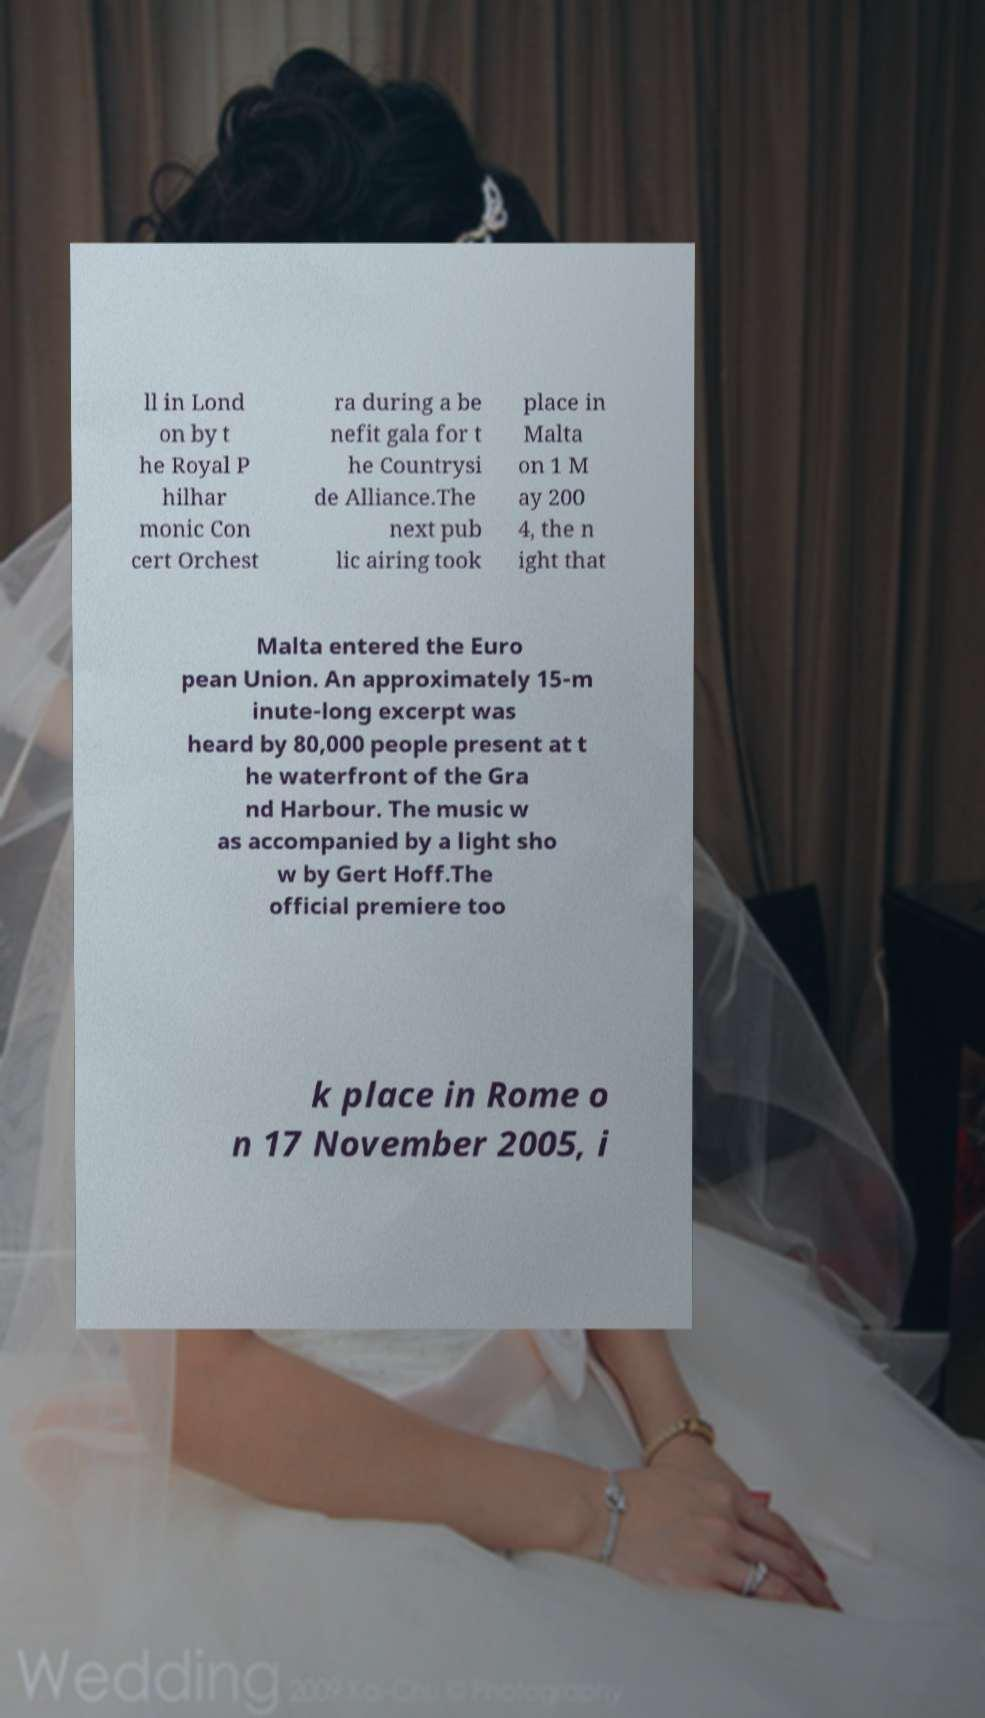For documentation purposes, I need the text within this image transcribed. Could you provide that? ll in Lond on by t he Royal P hilhar monic Con cert Orchest ra during a be nefit gala for t he Countrysi de Alliance.The next pub lic airing took place in Malta on 1 M ay 200 4, the n ight that Malta entered the Euro pean Union. An approximately 15-m inute-long excerpt was heard by 80,000 people present at t he waterfront of the Gra nd Harbour. The music w as accompanied by a light sho w by Gert Hoff.The official premiere too k place in Rome o n 17 November 2005, i 